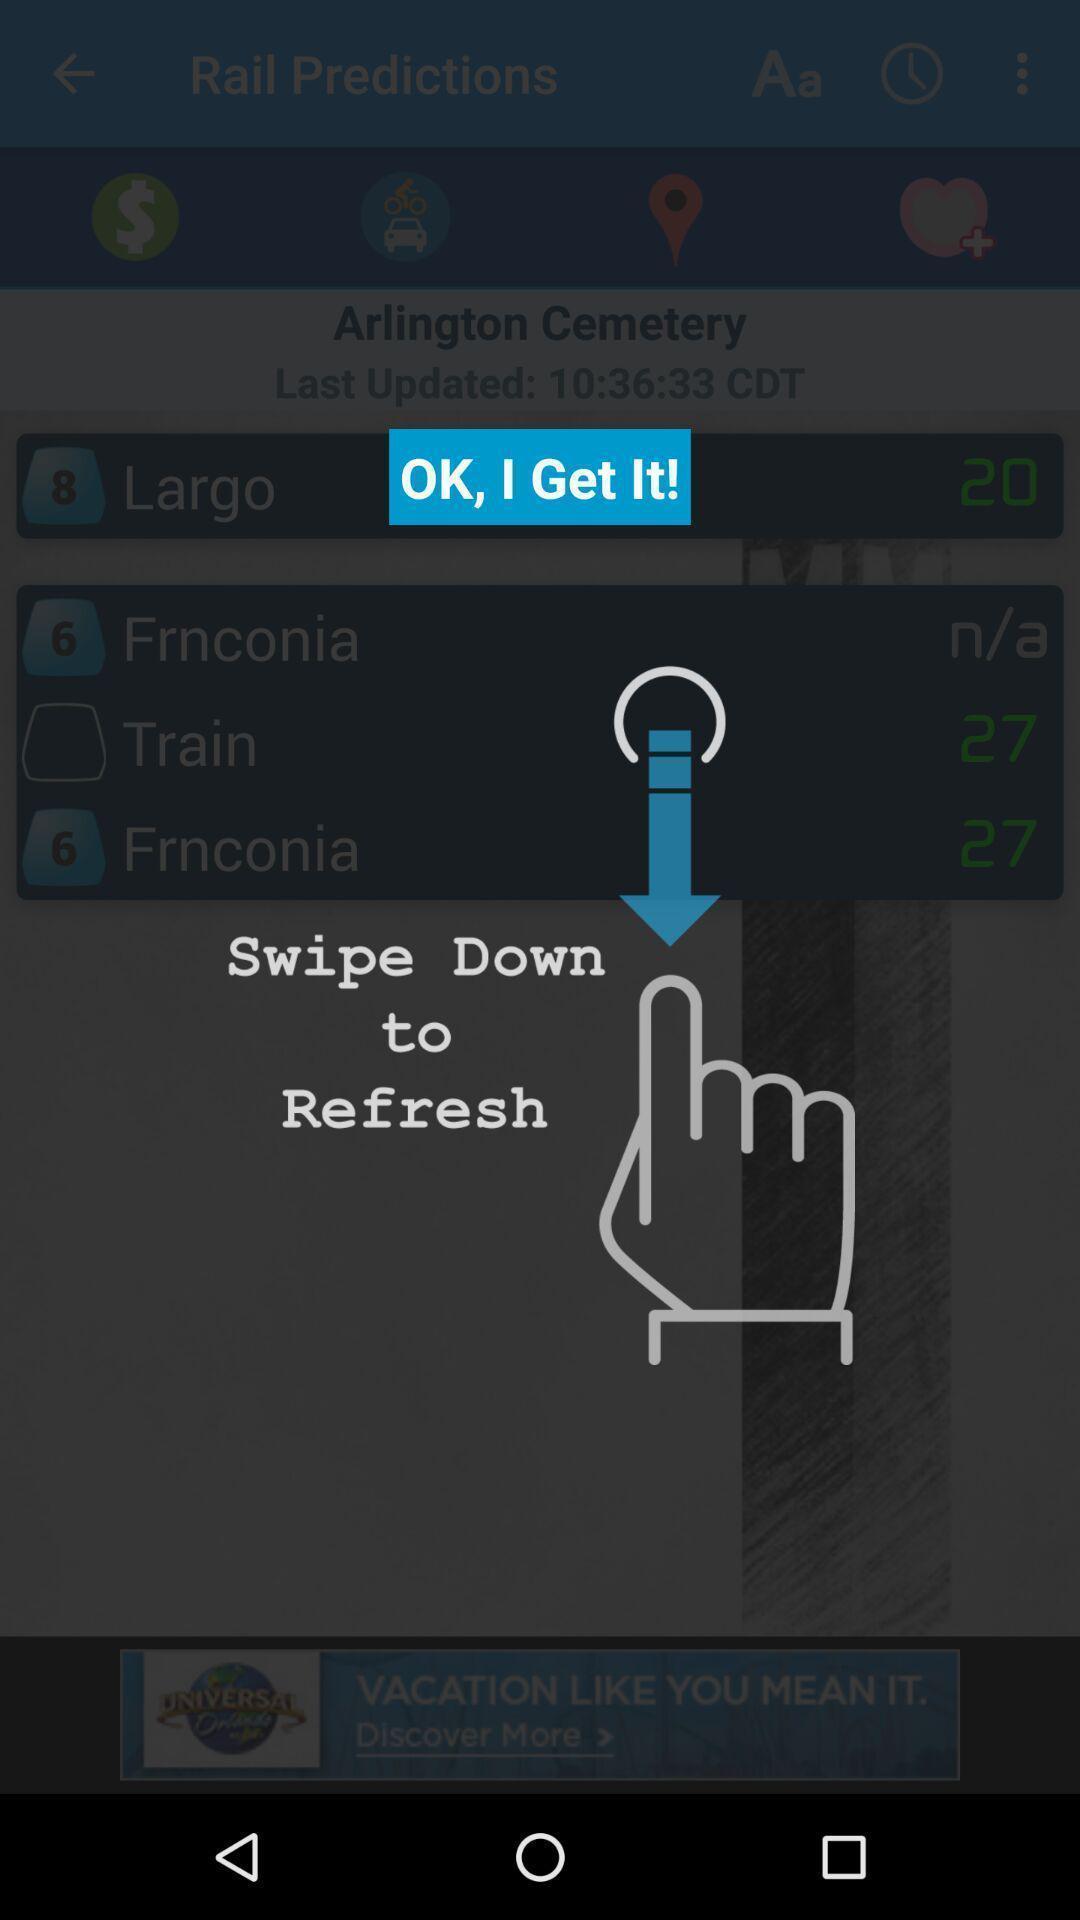Please provide a description for this image. Push up instruction page displaying for usage of app. 